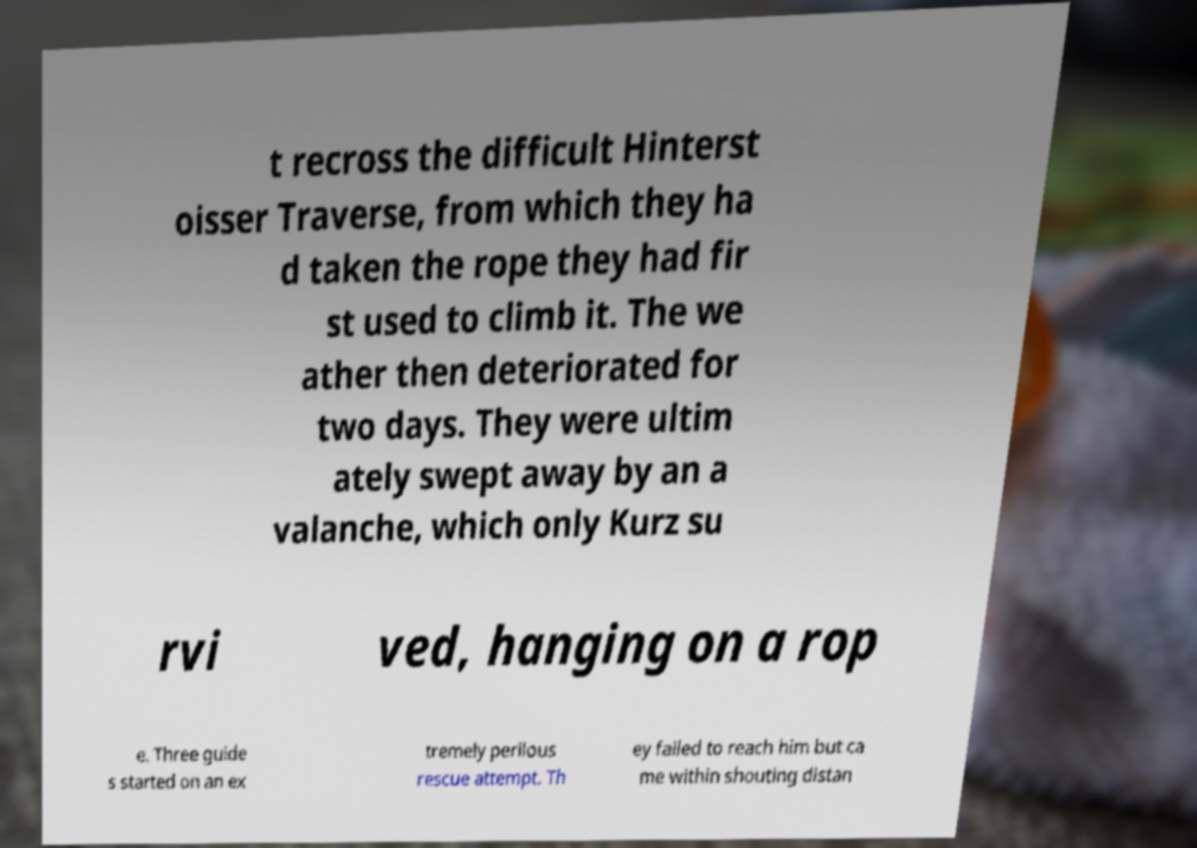Could you extract and type out the text from this image? t recross the difficult Hinterst oisser Traverse, from which they ha d taken the rope they had fir st used to climb it. The we ather then deteriorated for two days. They were ultim ately swept away by an a valanche, which only Kurz su rvi ved, hanging on a rop e. Three guide s started on an ex tremely perilous rescue attempt. Th ey failed to reach him but ca me within shouting distan 